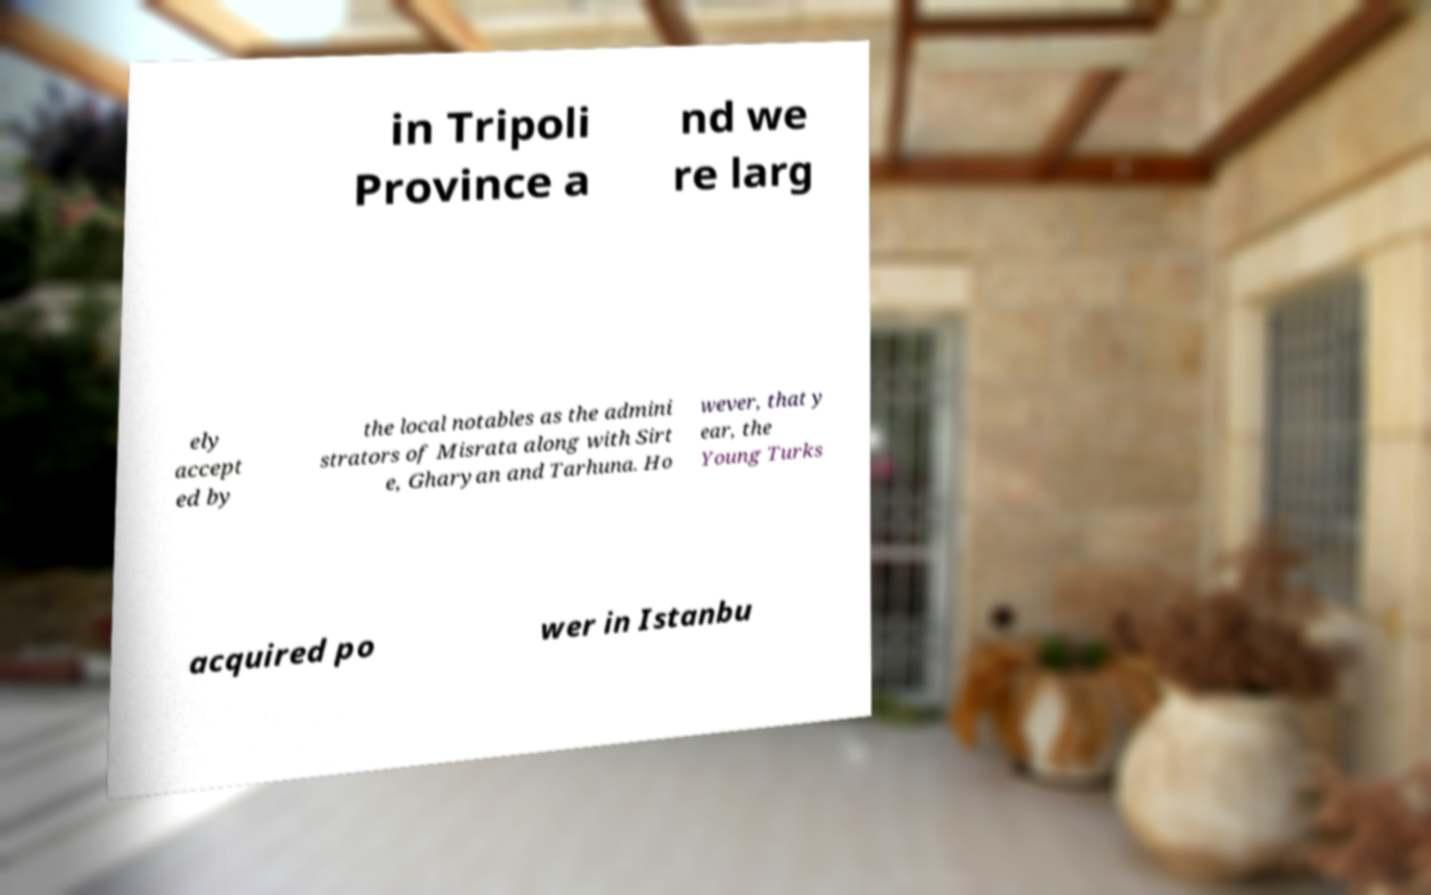There's text embedded in this image that I need extracted. Can you transcribe it verbatim? in Tripoli Province a nd we re larg ely accept ed by the local notables as the admini strators of Misrata along with Sirt e, Gharyan and Tarhuna. Ho wever, that y ear, the Young Turks acquired po wer in Istanbu 